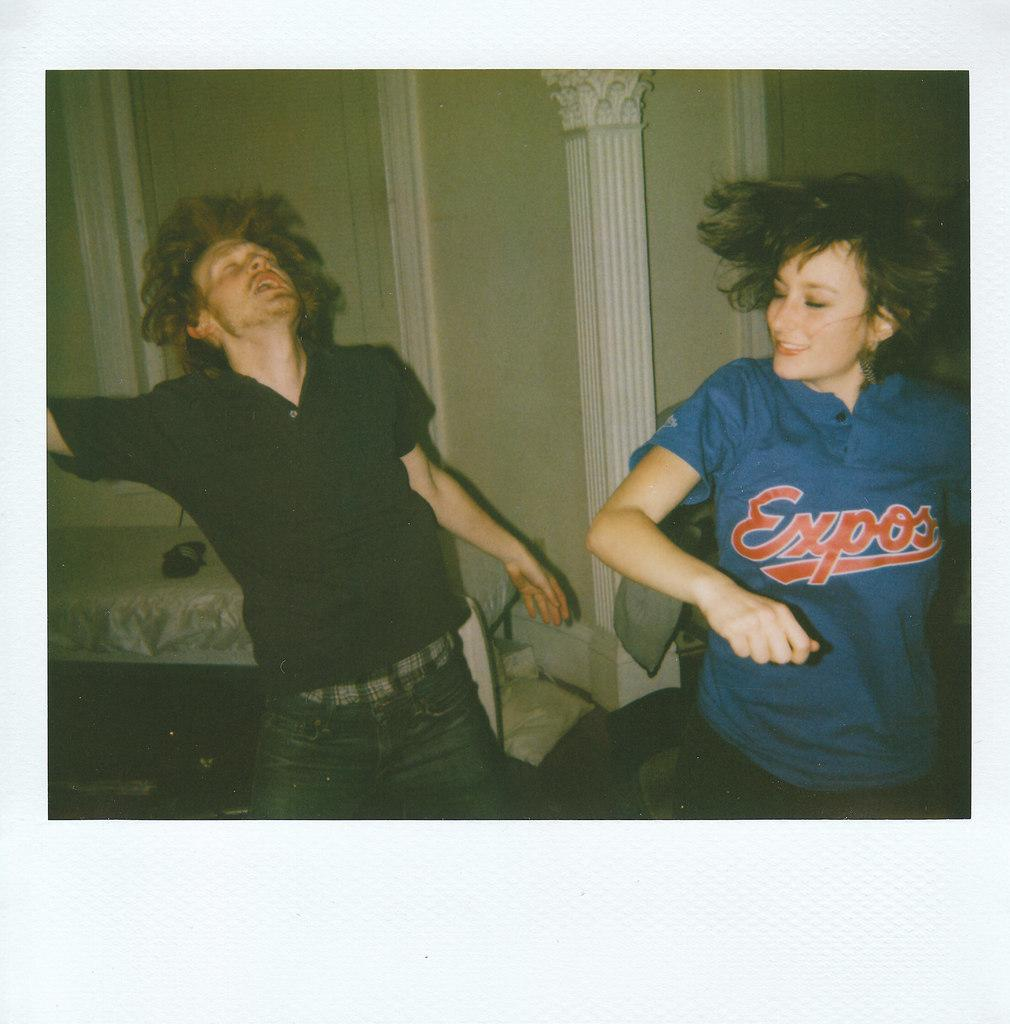Who are the people in the image? There is a girl and a boy in the image. What are the girl and boy doing in the image? The girl and boy are dancing. What can be seen in the background of the image? There is a pillar and a bed in the background of the image. What type of vacation is the girl and boy enjoying in the image? There is no indication of a vacation in the image; it simply shows the girl and boy dancing. At what angle is the girl and boy dancing in the image? The angle of the girl and boy dancing cannot be determined from the image alone, as it is a two-dimensional representation. 